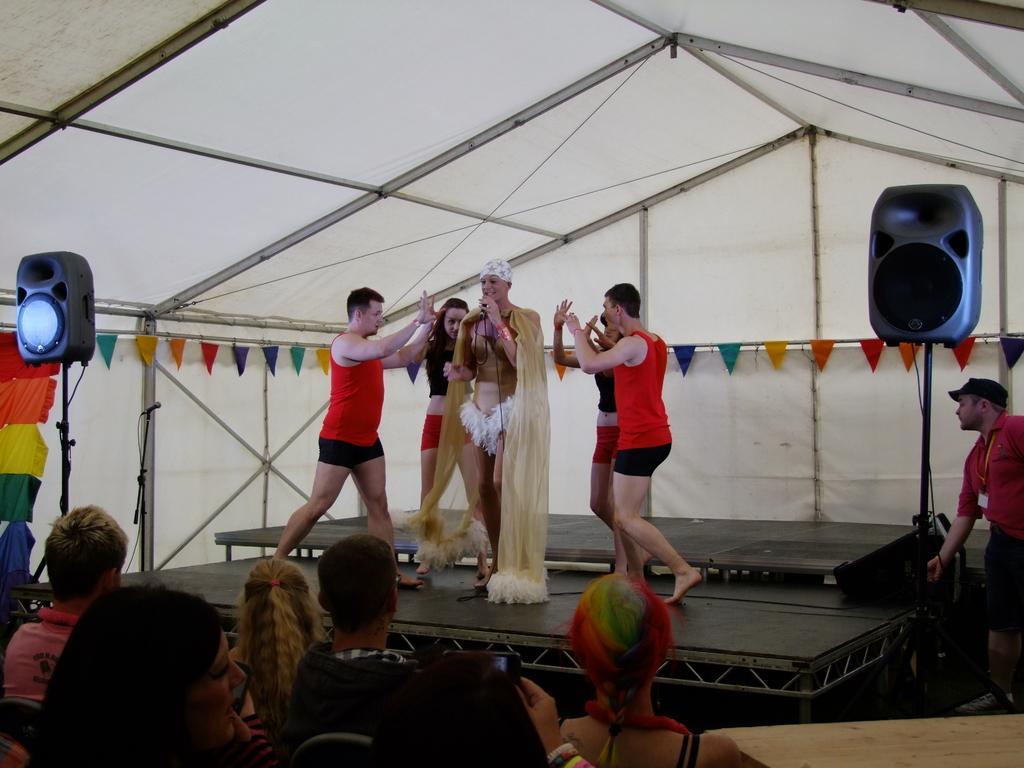Could you give a brief overview of what you see in this image? This is a picture taken from a concert or a drama. In the center of the picture on the stage there are people dancing. On the top it is tent. In the background there are ribbons. On the right there is a speaker and a person. In the foreground there are people sitting in chairs and a desk. On the left there is a speaker. 